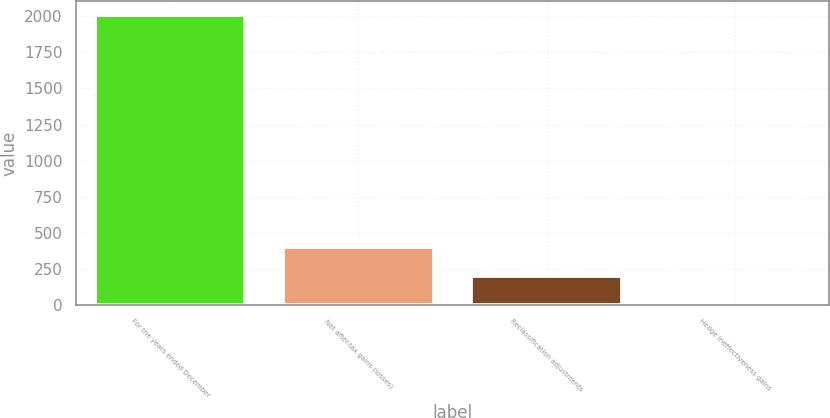Convert chart to OTSL. <chart><loc_0><loc_0><loc_500><loc_500><bar_chart><fcel>For the years ended December<fcel>Net after-tax gains (losses)<fcel>Reclassification adjustments<fcel>Hedge ineffectiveness gains<nl><fcel>2006<fcel>402.8<fcel>202.4<fcel>2<nl></chart> 